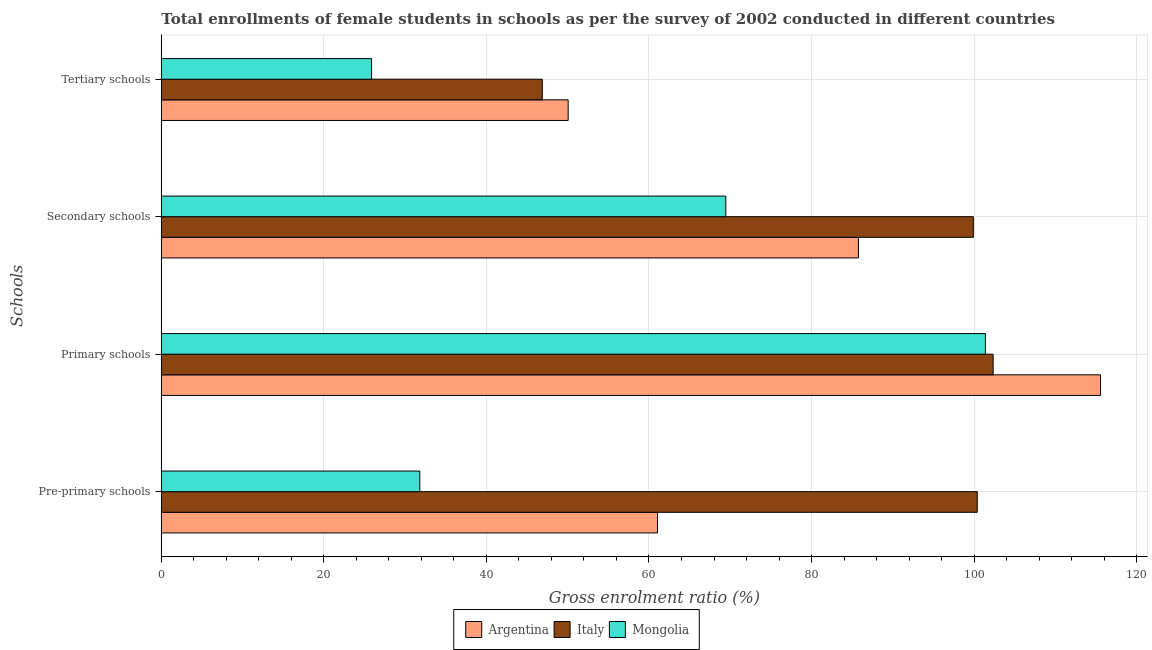How many groups of bars are there?
Give a very brief answer. 4. Are the number of bars per tick equal to the number of legend labels?
Make the answer very short. Yes. How many bars are there on the 4th tick from the top?
Your answer should be compact. 3. How many bars are there on the 4th tick from the bottom?
Keep it short and to the point. 3. What is the label of the 2nd group of bars from the top?
Provide a succinct answer. Secondary schools. What is the gross enrolment ratio(female) in pre-primary schools in Argentina?
Offer a very short reply. 61.05. Across all countries, what is the maximum gross enrolment ratio(female) in tertiary schools?
Offer a terse response. 50.06. Across all countries, what is the minimum gross enrolment ratio(female) in pre-primary schools?
Your response must be concise. 31.8. In which country was the gross enrolment ratio(female) in secondary schools maximum?
Offer a very short reply. Italy. In which country was the gross enrolment ratio(female) in tertiary schools minimum?
Provide a succinct answer. Mongolia. What is the total gross enrolment ratio(female) in tertiary schools in the graph?
Your response must be concise. 122.8. What is the difference between the gross enrolment ratio(female) in tertiary schools in Argentina and that in Italy?
Ensure brevity in your answer.  3.18. What is the difference between the gross enrolment ratio(female) in tertiary schools in Italy and the gross enrolment ratio(female) in secondary schools in Argentina?
Offer a very short reply. -38.9. What is the average gross enrolment ratio(female) in secondary schools per country?
Ensure brevity in your answer.  85.04. What is the difference between the gross enrolment ratio(female) in secondary schools and gross enrolment ratio(female) in pre-primary schools in Italy?
Provide a succinct answer. -0.48. In how many countries, is the gross enrolment ratio(female) in primary schools greater than 20 %?
Your answer should be very brief. 3. What is the ratio of the gross enrolment ratio(female) in primary schools in Italy to that in Argentina?
Ensure brevity in your answer.  0.89. What is the difference between the highest and the second highest gross enrolment ratio(female) in tertiary schools?
Offer a very short reply. 3.18. What is the difference between the highest and the lowest gross enrolment ratio(female) in secondary schools?
Your answer should be compact. 30.45. Is it the case that in every country, the sum of the gross enrolment ratio(female) in pre-primary schools and gross enrolment ratio(female) in primary schools is greater than the gross enrolment ratio(female) in secondary schools?
Make the answer very short. Yes. Are the values on the major ticks of X-axis written in scientific E-notation?
Make the answer very short. No. Does the graph contain grids?
Offer a terse response. Yes. Where does the legend appear in the graph?
Keep it short and to the point. Bottom center. What is the title of the graph?
Your answer should be very brief. Total enrollments of female students in schools as per the survey of 2002 conducted in different countries. Does "Madagascar" appear as one of the legend labels in the graph?
Offer a terse response. No. What is the label or title of the Y-axis?
Provide a succinct answer. Schools. What is the Gross enrolment ratio (%) of Argentina in Pre-primary schools?
Give a very brief answer. 61.05. What is the Gross enrolment ratio (%) in Italy in Pre-primary schools?
Give a very brief answer. 100.39. What is the Gross enrolment ratio (%) of Mongolia in Pre-primary schools?
Ensure brevity in your answer.  31.8. What is the Gross enrolment ratio (%) of Argentina in Primary schools?
Offer a very short reply. 115.56. What is the Gross enrolment ratio (%) in Italy in Primary schools?
Make the answer very short. 102.34. What is the Gross enrolment ratio (%) of Mongolia in Primary schools?
Offer a very short reply. 101.39. What is the Gross enrolment ratio (%) in Argentina in Secondary schools?
Ensure brevity in your answer.  85.77. What is the Gross enrolment ratio (%) of Italy in Secondary schools?
Offer a terse response. 99.91. What is the Gross enrolment ratio (%) in Mongolia in Secondary schools?
Ensure brevity in your answer.  69.45. What is the Gross enrolment ratio (%) in Argentina in Tertiary schools?
Give a very brief answer. 50.06. What is the Gross enrolment ratio (%) of Italy in Tertiary schools?
Your response must be concise. 46.87. What is the Gross enrolment ratio (%) of Mongolia in Tertiary schools?
Give a very brief answer. 25.87. Across all Schools, what is the maximum Gross enrolment ratio (%) of Argentina?
Your answer should be compact. 115.56. Across all Schools, what is the maximum Gross enrolment ratio (%) in Italy?
Provide a short and direct response. 102.34. Across all Schools, what is the maximum Gross enrolment ratio (%) in Mongolia?
Make the answer very short. 101.39. Across all Schools, what is the minimum Gross enrolment ratio (%) of Argentina?
Give a very brief answer. 50.06. Across all Schools, what is the minimum Gross enrolment ratio (%) in Italy?
Offer a very short reply. 46.87. Across all Schools, what is the minimum Gross enrolment ratio (%) in Mongolia?
Your response must be concise. 25.87. What is the total Gross enrolment ratio (%) in Argentina in the graph?
Ensure brevity in your answer.  312.44. What is the total Gross enrolment ratio (%) of Italy in the graph?
Your answer should be very brief. 349.51. What is the total Gross enrolment ratio (%) of Mongolia in the graph?
Your answer should be compact. 228.52. What is the difference between the Gross enrolment ratio (%) in Argentina in Pre-primary schools and that in Primary schools?
Your response must be concise. -54.51. What is the difference between the Gross enrolment ratio (%) of Italy in Pre-primary schools and that in Primary schools?
Offer a very short reply. -1.96. What is the difference between the Gross enrolment ratio (%) in Mongolia in Pre-primary schools and that in Primary schools?
Offer a very short reply. -69.59. What is the difference between the Gross enrolment ratio (%) of Argentina in Pre-primary schools and that in Secondary schools?
Provide a short and direct response. -24.73. What is the difference between the Gross enrolment ratio (%) in Italy in Pre-primary schools and that in Secondary schools?
Your answer should be compact. 0.48. What is the difference between the Gross enrolment ratio (%) in Mongolia in Pre-primary schools and that in Secondary schools?
Give a very brief answer. -37.65. What is the difference between the Gross enrolment ratio (%) of Argentina in Pre-primary schools and that in Tertiary schools?
Make the answer very short. 10.99. What is the difference between the Gross enrolment ratio (%) in Italy in Pre-primary schools and that in Tertiary schools?
Make the answer very short. 53.52. What is the difference between the Gross enrolment ratio (%) of Mongolia in Pre-primary schools and that in Tertiary schools?
Give a very brief answer. 5.93. What is the difference between the Gross enrolment ratio (%) of Argentina in Primary schools and that in Secondary schools?
Your answer should be compact. 29.78. What is the difference between the Gross enrolment ratio (%) in Italy in Primary schools and that in Secondary schools?
Your answer should be very brief. 2.44. What is the difference between the Gross enrolment ratio (%) of Mongolia in Primary schools and that in Secondary schools?
Provide a succinct answer. 31.94. What is the difference between the Gross enrolment ratio (%) in Argentina in Primary schools and that in Tertiary schools?
Offer a very short reply. 65.5. What is the difference between the Gross enrolment ratio (%) in Italy in Primary schools and that in Tertiary schools?
Provide a succinct answer. 55.47. What is the difference between the Gross enrolment ratio (%) of Mongolia in Primary schools and that in Tertiary schools?
Offer a terse response. 75.52. What is the difference between the Gross enrolment ratio (%) in Argentina in Secondary schools and that in Tertiary schools?
Keep it short and to the point. 35.72. What is the difference between the Gross enrolment ratio (%) in Italy in Secondary schools and that in Tertiary schools?
Offer a very short reply. 53.03. What is the difference between the Gross enrolment ratio (%) of Mongolia in Secondary schools and that in Tertiary schools?
Your response must be concise. 43.58. What is the difference between the Gross enrolment ratio (%) of Argentina in Pre-primary schools and the Gross enrolment ratio (%) of Italy in Primary schools?
Make the answer very short. -41.3. What is the difference between the Gross enrolment ratio (%) of Argentina in Pre-primary schools and the Gross enrolment ratio (%) of Mongolia in Primary schools?
Ensure brevity in your answer.  -40.34. What is the difference between the Gross enrolment ratio (%) in Italy in Pre-primary schools and the Gross enrolment ratio (%) in Mongolia in Primary schools?
Provide a short and direct response. -1. What is the difference between the Gross enrolment ratio (%) in Argentina in Pre-primary schools and the Gross enrolment ratio (%) in Italy in Secondary schools?
Make the answer very short. -38.86. What is the difference between the Gross enrolment ratio (%) in Argentina in Pre-primary schools and the Gross enrolment ratio (%) in Mongolia in Secondary schools?
Your response must be concise. -8.41. What is the difference between the Gross enrolment ratio (%) of Italy in Pre-primary schools and the Gross enrolment ratio (%) of Mongolia in Secondary schools?
Your answer should be compact. 30.94. What is the difference between the Gross enrolment ratio (%) in Argentina in Pre-primary schools and the Gross enrolment ratio (%) in Italy in Tertiary schools?
Keep it short and to the point. 14.17. What is the difference between the Gross enrolment ratio (%) in Argentina in Pre-primary schools and the Gross enrolment ratio (%) in Mongolia in Tertiary schools?
Offer a very short reply. 35.18. What is the difference between the Gross enrolment ratio (%) in Italy in Pre-primary schools and the Gross enrolment ratio (%) in Mongolia in Tertiary schools?
Your response must be concise. 74.52. What is the difference between the Gross enrolment ratio (%) of Argentina in Primary schools and the Gross enrolment ratio (%) of Italy in Secondary schools?
Make the answer very short. 15.65. What is the difference between the Gross enrolment ratio (%) in Argentina in Primary schools and the Gross enrolment ratio (%) in Mongolia in Secondary schools?
Your answer should be compact. 46.1. What is the difference between the Gross enrolment ratio (%) of Italy in Primary schools and the Gross enrolment ratio (%) of Mongolia in Secondary schools?
Make the answer very short. 32.89. What is the difference between the Gross enrolment ratio (%) of Argentina in Primary schools and the Gross enrolment ratio (%) of Italy in Tertiary schools?
Your response must be concise. 68.68. What is the difference between the Gross enrolment ratio (%) of Argentina in Primary schools and the Gross enrolment ratio (%) of Mongolia in Tertiary schools?
Your response must be concise. 89.69. What is the difference between the Gross enrolment ratio (%) of Italy in Primary schools and the Gross enrolment ratio (%) of Mongolia in Tertiary schools?
Provide a succinct answer. 76.47. What is the difference between the Gross enrolment ratio (%) in Argentina in Secondary schools and the Gross enrolment ratio (%) in Italy in Tertiary schools?
Offer a very short reply. 38.9. What is the difference between the Gross enrolment ratio (%) in Argentina in Secondary schools and the Gross enrolment ratio (%) in Mongolia in Tertiary schools?
Ensure brevity in your answer.  59.9. What is the difference between the Gross enrolment ratio (%) of Italy in Secondary schools and the Gross enrolment ratio (%) of Mongolia in Tertiary schools?
Your answer should be very brief. 74.04. What is the average Gross enrolment ratio (%) in Argentina per Schools?
Your answer should be very brief. 78.11. What is the average Gross enrolment ratio (%) of Italy per Schools?
Your answer should be very brief. 87.38. What is the average Gross enrolment ratio (%) of Mongolia per Schools?
Your answer should be very brief. 57.13. What is the difference between the Gross enrolment ratio (%) in Argentina and Gross enrolment ratio (%) in Italy in Pre-primary schools?
Keep it short and to the point. -39.34. What is the difference between the Gross enrolment ratio (%) of Argentina and Gross enrolment ratio (%) of Mongolia in Pre-primary schools?
Provide a short and direct response. 29.24. What is the difference between the Gross enrolment ratio (%) of Italy and Gross enrolment ratio (%) of Mongolia in Pre-primary schools?
Provide a short and direct response. 68.58. What is the difference between the Gross enrolment ratio (%) of Argentina and Gross enrolment ratio (%) of Italy in Primary schools?
Offer a terse response. 13.21. What is the difference between the Gross enrolment ratio (%) of Argentina and Gross enrolment ratio (%) of Mongolia in Primary schools?
Give a very brief answer. 14.17. What is the difference between the Gross enrolment ratio (%) in Italy and Gross enrolment ratio (%) in Mongolia in Primary schools?
Your answer should be very brief. 0.95. What is the difference between the Gross enrolment ratio (%) in Argentina and Gross enrolment ratio (%) in Italy in Secondary schools?
Your answer should be compact. -14.13. What is the difference between the Gross enrolment ratio (%) in Argentina and Gross enrolment ratio (%) in Mongolia in Secondary schools?
Give a very brief answer. 16.32. What is the difference between the Gross enrolment ratio (%) of Italy and Gross enrolment ratio (%) of Mongolia in Secondary schools?
Offer a terse response. 30.45. What is the difference between the Gross enrolment ratio (%) in Argentina and Gross enrolment ratio (%) in Italy in Tertiary schools?
Make the answer very short. 3.18. What is the difference between the Gross enrolment ratio (%) of Argentina and Gross enrolment ratio (%) of Mongolia in Tertiary schools?
Your answer should be compact. 24.18. What is the difference between the Gross enrolment ratio (%) of Italy and Gross enrolment ratio (%) of Mongolia in Tertiary schools?
Your answer should be very brief. 21. What is the ratio of the Gross enrolment ratio (%) in Argentina in Pre-primary schools to that in Primary schools?
Your answer should be compact. 0.53. What is the ratio of the Gross enrolment ratio (%) in Italy in Pre-primary schools to that in Primary schools?
Provide a short and direct response. 0.98. What is the ratio of the Gross enrolment ratio (%) in Mongolia in Pre-primary schools to that in Primary schools?
Your answer should be compact. 0.31. What is the ratio of the Gross enrolment ratio (%) of Argentina in Pre-primary schools to that in Secondary schools?
Ensure brevity in your answer.  0.71. What is the ratio of the Gross enrolment ratio (%) in Italy in Pre-primary schools to that in Secondary schools?
Keep it short and to the point. 1. What is the ratio of the Gross enrolment ratio (%) in Mongolia in Pre-primary schools to that in Secondary schools?
Ensure brevity in your answer.  0.46. What is the ratio of the Gross enrolment ratio (%) of Argentina in Pre-primary schools to that in Tertiary schools?
Offer a terse response. 1.22. What is the ratio of the Gross enrolment ratio (%) of Italy in Pre-primary schools to that in Tertiary schools?
Your response must be concise. 2.14. What is the ratio of the Gross enrolment ratio (%) of Mongolia in Pre-primary schools to that in Tertiary schools?
Your answer should be very brief. 1.23. What is the ratio of the Gross enrolment ratio (%) of Argentina in Primary schools to that in Secondary schools?
Your answer should be compact. 1.35. What is the ratio of the Gross enrolment ratio (%) of Italy in Primary schools to that in Secondary schools?
Give a very brief answer. 1.02. What is the ratio of the Gross enrolment ratio (%) in Mongolia in Primary schools to that in Secondary schools?
Keep it short and to the point. 1.46. What is the ratio of the Gross enrolment ratio (%) of Argentina in Primary schools to that in Tertiary schools?
Provide a succinct answer. 2.31. What is the ratio of the Gross enrolment ratio (%) of Italy in Primary schools to that in Tertiary schools?
Your response must be concise. 2.18. What is the ratio of the Gross enrolment ratio (%) of Mongolia in Primary schools to that in Tertiary schools?
Ensure brevity in your answer.  3.92. What is the ratio of the Gross enrolment ratio (%) of Argentina in Secondary schools to that in Tertiary schools?
Ensure brevity in your answer.  1.71. What is the ratio of the Gross enrolment ratio (%) in Italy in Secondary schools to that in Tertiary schools?
Ensure brevity in your answer.  2.13. What is the ratio of the Gross enrolment ratio (%) of Mongolia in Secondary schools to that in Tertiary schools?
Give a very brief answer. 2.68. What is the difference between the highest and the second highest Gross enrolment ratio (%) in Argentina?
Ensure brevity in your answer.  29.78. What is the difference between the highest and the second highest Gross enrolment ratio (%) in Italy?
Keep it short and to the point. 1.96. What is the difference between the highest and the second highest Gross enrolment ratio (%) of Mongolia?
Provide a succinct answer. 31.94. What is the difference between the highest and the lowest Gross enrolment ratio (%) of Argentina?
Your answer should be very brief. 65.5. What is the difference between the highest and the lowest Gross enrolment ratio (%) of Italy?
Ensure brevity in your answer.  55.47. What is the difference between the highest and the lowest Gross enrolment ratio (%) in Mongolia?
Your answer should be very brief. 75.52. 